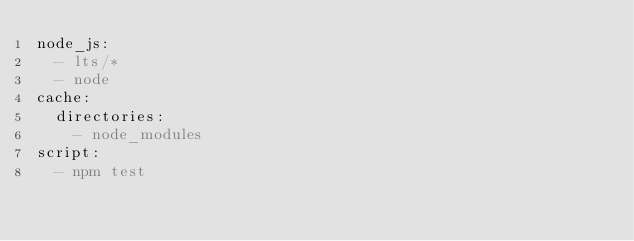<code> <loc_0><loc_0><loc_500><loc_500><_YAML_>node_js:
  - lts/*
  - node
cache:
  directories:
    - node_modules
script:
  - npm test
</code> 